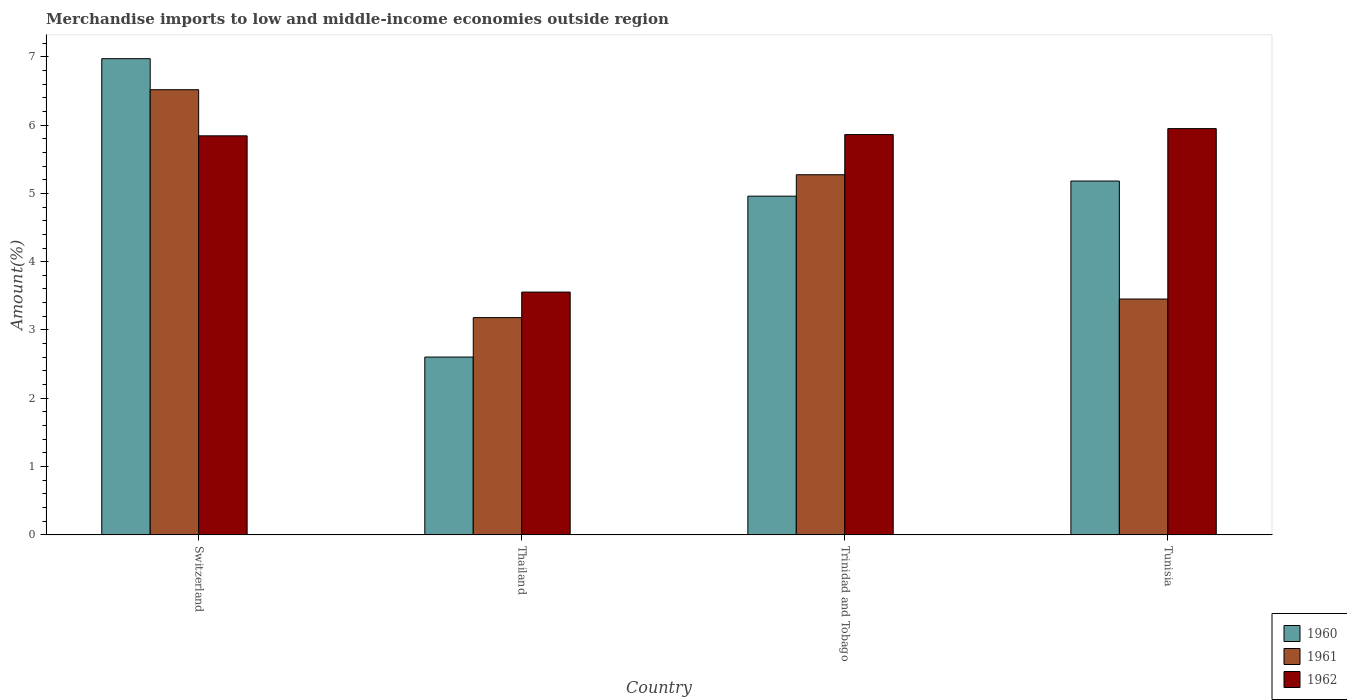How many groups of bars are there?
Ensure brevity in your answer.  4. Are the number of bars on each tick of the X-axis equal?
Your response must be concise. Yes. What is the label of the 4th group of bars from the left?
Make the answer very short. Tunisia. In how many cases, is the number of bars for a given country not equal to the number of legend labels?
Your response must be concise. 0. What is the percentage of amount earned from merchandise imports in 1962 in Thailand?
Your answer should be very brief. 3.55. Across all countries, what is the maximum percentage of amount earned from merchandise imports in 1962?
Provide a succinct answer. 5.95. Across all countries, what is the minimum percentage of amount earned from merchandise imports in 1962?
Provide a succinct answer. 3.55. In which country was the percentage of amount earned from merchandise imports in 1961 maximum?
Ensure brevity in your answer.  Switzerland. In which country was the percentage of amount earned from merchandise imports in 1962 minimum?
Your response must be concise. Thailand. What is the total percentage of amount earned from merchandise imports in 1960 in the graph?
Keep it short and to the point. 19.71. What is the difference between the percentage of amount earned from merchandise imports in 1960 in Thailand and that in Trinidad and Tobago?
Provide a succinct answer. -2.36. What is the difference between the percentage of amount earned from merchandise imports in 1960 in Switzerland and the percentage of amount earned from merchandise imports in 1961 in Tunisia?
Your answer should be compact. 3.52. What is the average percentage of amount earned from merchandise imports in 1960 per country?
Ensure brevity in your answer.  4.93. What is the difference between the percentage of amount earned from merchandise imports of/in 1962 and percentage of amount earned from merchandise imports of/in 1961 in Tunisia?
Your answer should be compact. 2.49. What is the ratio of the percentage of amount earned from merchandise imports in 1962 in Switzerland to that in Trinidad and Tobago?
Make the answer very short. 1. Is the percentage of amount earned from merchandise imports in 1962 in Thailand less than that in Trinidad and Tobago?
Offer a terse response. Yes. Is the difference between the percentage of amount earned from merchandise imports in 1962 in Trinidad and Tobago and Tunisia greater than the difference between the percentage of amount earned from merchandise imports in 1961 in Trinidad and Tobago and Tunisia?
Offer a very short reply. No. What is the difference between the highest and the second highest percentage of amount earned from merchandise imports in 1960?
Offer a very short reply. -0.22. What is the difference between the highest and the lowest percentage of amount earned from merchandise imports in 1960?
Provide a succinct answer. 4.37. Is the sum of the percentage of amount earned from merchandise imports in 1960 in Thailand and Tunisia greater than the maximum percentage of amount earned from merchandise imports in 1962 across all countries?
Provide a short and direct response. Yes. What does the 2nd bar from the left in Tunisia represents?
Give a very brief answer. 1961. What does the 1st bar from the right in Switzerland represents?
Keep it short and to the point. 1962. How many countries are there in the graph?
Give a very brief answer. 4. Are the values on the major ticks of Y-axis written in scientific E-notation?
Your answer should be compact. No. Does the graph contain grids?
Provide a short and direct response. No. How many legend labels are there?
Offer a terse response. 3. How are the legend labels stacked?
Offer a very short reply. Vertical. What is the title of the graph?
Make the answer very short. Merchandise imports to low and middle-income economies outside region. What is the label or title of the X-axis?
Your answer should be compact. Country. What is the label or title of the Y-axis?
Give a very brief answer. Amount(%). What is the Amount(%) of 1960 in Switzerland?
Give a very brief answer. 6.97. What is the Amount(%) in 1961 in Switzerland?
Your response must be concise. 6.52. What is the Amount(%) in 1962 in Switzerland?
Offer a terse response. 5.84. What is the Amount(%) in 1960 in Thailand?
Ensure brevity in your answer.  2.6. What is the Amount(%) in 1961 in Thailand?
Ensure brevity in your answer.  3.18. What is the Amount(%) in 1962 in Thailand?
Offer a very short reply. 3.55. What is the Amount(%) of 1960 in Trinidad and Tobago?
Provide a succinct answer. 4.96. What is the Amount(%) in 1961 in Trinidad and Tobago?
Your answer should be very brief. 5.27. What is the Amount(%) of 1962 in Trinidad and Tobago?
Your response must be concise. 5.86. What is the Amount(%) in 1960 in Tunisia?
Provide a short and direct response. 5.18. What is the Amount(%) of 1961 in Tunisia?
Keep it short and to the point. 3.45. What is the Amount(%) in 1962 in Tunisia?
Provide a succinct answer. 5.95. Across all countries, what is the maximum Amount(%) in 1960?
Your answer should be very brief. 6.97. Across all countries, what is the maximum Amount(%) of 1961?
Offer a terse response. 6.52. Across all countries, what is the maximum Amount(%) of 1962?
Your response must be concise. 5.95. Across all countries, what is the minimum Amount(%) of 1960?
Your answer should be very brief. 2.6. Across all countries, what is the minimum Amount(%) in 1961?
Your response must be concise. 3.18. Across all countries, what is the minimum Amount(%) in 1962?
Offer a very short reply. 3.55. What is the total Amount(%) of 1960 in the graph?
Give a very brief answer. 19.71. What is the total Amount(%) of 1961 in the graph?
Keep it short and to the point. 18.42. What is the total Amount(%) in 1962 in the graph?
Your answer should be compact. 21.21. What is the difference between the Amount(%) of 1960 in Switzerland and that in Thailand?
Offer a very short reply. 4.37. What is the difference between the Amount(%) in 1961 in Switzerland and that in Thailand?
Keep it short and to the point. 3.34. What is the difference between the Amount(%) in 1962 in Switzerland and that in Thailand?
Your answer should be very brief. 2.29. What is the difference between the Amount(%) of 1960 in Switzerland and that in Trinidad and Tobago?
Your answer should be compact. 2.01. What is the difference between the Amount(%) of 1961 in Switzerland and that in Trinidad and Tobago?
Keep it short and to the point. 1.25. What is the difference between the Amount(%) in 1962 in Switzerland and that in Trinidad and Tobago?
Ensure brevity in your answer.  -0.02. What is the difference between the Amount(%) of 1960 in Switzerland and that in Tunisia?
Provide a succinct answer. 1.79. What is the difference between the Amount(%) in 1961 in Switzerland and that in Tunisia?
Make the answer very short. 3.06. What is the difference between the Amount(%) in 1962 in Switzerland and that in Tunisia?
Make the answer very short. -0.11. What is the difference between the Amount(%) in 1960 in Thailand and that in Trinidad and Tobago?
Make the answer very short. -2.36. What is the difference between the Amount(%) in 1961 in Thailand and that in Trinidad and Tobago?
Give a very brief answer. -2.09. What is the difference between the Amount(%) of 1962 in Thailand and that in Trinidad and Tobago?
Provide a succinct answer. -2.31. What is the difference between the Amount(%) in 1960 in Thailand and that in Tunisia?
Provide a short and direct response. -2.58. What is the difference between the Amount(%) of 1961 in Thailand and that in Tunisia?
Your answer should be very brief. -0.27. What is the difference between the Amount(%) in 1962 in Thailand and that in Tunisia?
Ensure brevity in your answer.  -2.39. What is the difference between the Amount(%) in 1960 in Trinidad and Tobago and that in Tunisia?
Provide a succinct answer. -0.22. What is the difference between the Amount(%) of 1961 in Trinidad and Tobago and that in Tunisia?
Provide a succinct answer. 1.82. What is the difference between the Amount(%) of 1962 in Trinidad and Tobago and that in Tunisia?
Make the answer very short. -0.09. What is the difference between the Amount(%) of 1960 in Switzerland and the Amount(%) of 1961 in Thailand?
Your answer should be very brief. 3.79. What is the difference between the Amount(%) of 1960 in Switzerland and the Amount(%) of 1962 in Thailand?
Ensure brevity in your answer.  3.42. What is the difference between the Amount(%) in 1961 in Switzerland and the Amount(%) in 1962 in Thailand?
Give a very brief answer. 2.96. What is the difference between the Amount(%) in 1960 in Switzerland and the Amount(%) in 1961 in Trinidad and Tobago?
Give a very brief answer. 1.7. What is the difference between the Amount(%) of 1960 in Switzerland and the Amount(%) of 1962 in Trinidad and Tobago?
Make the answer very short. 1.11. What is the difference between the Amount(%) of 1961 in Switzerland and the Amount(%) of 1962 in Trinidad and Tobago?
Make the answer very short. 0.66. What is the difference between the Amount(%) in 1960 in Switzerland and the Amount(%) in 1961 in Tunisia?
Your response must be concise. 3.52. What is the difference between the Amount(%) of 1960 in Switzerland and the Amount(%) of 1962 in Tunisia?
Keep it short and to the point. 1.02. What is the difference between the Amount(%) in 1961 in Switzerland and the Amount(%) in 1962 in Tunisia?
Keep it short and to the point. 0.57. What is the difference between the Amount(%) in 1960 in Thailand and the Amount(%) in 1961 in Trinidad and Tobago?
Provide a succinct answer. -2.67. What is the difference between the Amount(%) in 1960 in Thailand and the Amount(%) in 1962 in Trinidad and Tobago?
Offer a terse response. -3.26. What is the difference between the Amount(%) in 1961 in Thailand and the Amount(%) in 1962 in Trinidad and Tobago?
Offer a very short reply. -2.68. What is the difference between the Amount(%) of 1960 in Thailand and the Amount(%) of 1961 in Tunisia?
Your answer should be very brief. -0.85. What is the difference between the Amount(%) of 1960 in Thailand and the Amount(%) of 1962 in Tunisia?
Keep it short and to the point. -3.34. What is the difference between the Amount(%) of 1961 in Thailand and the Amount(%) of 1962 in Tunisia?
Ensure brevity in your answer.  -2.77. What is the difference between the Amount(%) in 1960 in Trinidad and Tobago and the Amount(%) in 1961 in Tunisia?
Give a very brief answer. 1.51. What is the difference between the Amount(%) of 1960 in Trinidad and Tobago and the Amount(%) of 1962 in Tunisia?
Offer a terse response. -0.99. What is the difference between the Amount(%) in 1961 in Trinidad and Tobago and the Amount(%) in 1962 in Tunisia?
Ensure brevity in your answer.  -0.68. What is the average Amount(%) in 1960 per country?
Give a very brief answer. 4.93. What is the average Amount(%) in 1961 per country?
Offer a terse response. 4.61. What is the average Amount(%) of 1962 per country?
Your answer should be very brief. 5.3. What is the difference between the Amount(%) in 1960 and Amount(%) in 1961 in Switzerland?
Your answer should be very brief. 0.45. What is the difference between the Amount(%) of 1960 and Amount(%) of 1962 in Switzerland?
Your response must be concise. 1.13. What is the difference between the Amount(%) of 1961 and Amount(%) of 1962 in Switzerland?
Provide a succinct answer. 0.68. What is the difference between the Amount(%) in 1960 and Amount(%) in 1961 in Thailand?
Offer a terse response. -0.58. What is the difference between the Amount(%) of 1960 and Amount(%) of 1962 in Thailand?
Your answer should be compact. -0.95. What is the difference between the Amount(%) of 1961 and Amount(%) of 1962 in Thailand?
Offer a terse response. -0.37. What is the difference between the Amount(%) of 1960 and Amount(%) of 1961 in Trinidad and Tobago?
Offer a very short reply. -0.31. What is the difference between the Amount(%) of 1960 and Amount(%) of 1962 in Trinidad and Tobago?
Provide a short and direct response. -0.9. What is the difference between the Amount(%) in 1961 and Amount(%) in 1962 in Trinidad and Tobago?
Your answer should be very brief. -0.59. What is the difference between the Amount(%) in 1960 and Amount(%) in 1961 in Tunisia?
Give a very brief answer. 1.73. What is the difference between the Amount(%) of 1960 and Amount(%) of 1962 in Tunisia?
Keep it short and to the point. -0.77. What is the difference between the Amount(%) of 1961 and Amount(%) of 1962 in Tunisia?
Offer a terse response. -2.49. What is the ratio of the Amount(%) in 1960 in Switzerland to that in Thailand?
Offer a terse response. 2.68. What is the ratio of the Amount(%) of 1961 in Switzerland to that in Thailand?
Provide a succinct answer. 2.05. What is the ratio of the Amount(%) of 1962 in Switzerland to that in Thailand?
Give a very brief answer. 1.64. What is the ratio of the Amount(%) in 1960 in Switzerland to that in Trinidad and Tobago?
Make the answer very short. 1.41. What is the ratio of the Amount(%) in 1961 in Switzerland to that in Trinidad and Tobago?
Provide a succinct answer. 1.24. What is the ratio of the Amount(%) in 1960 in Switzerland to that in Tunisia?
Provide a short and direct response. 1.35. What is the ratio of the Amount(%) in 1961 in Switzerland to that in Tunisia?
Offer a very short reply. 1.89. What is the ratio of the Amount(%) of 1962 in Switzerland to that in Tunisia?
Provide a succinct answer. 0.98. What is the ratio of the Amount(%) of 1960 in Thailand to that in Trinidad and Tobago?
Provide a succinct answer. 0.53. What is the ratio of the Amount(%) of 1961 in Thailand to that in Trinidad and Tobago?
Your answer should be compact. 0.6. What is the ratio of the Amount(%) of 1962 in Thailand to that in Trinidad and Tobago?
Your answer should be compact. 0.61. What is the ratio of the Amount(%) of 1960 in Thailand to that in Tunisia?
Ensure brevity in your answer.  0.5. What is the ratio of the Amount(%) of 1961 in Thailand to that in Tunisia?
Provide a short and direct response. 0.92. What is the ratio of the Amount(%) in 1962 in Thailand to that in Tunisia?
Ensure brevity in your answer.  0.6. What is the ratio of the Amount(%) of 1960 in Trinidad and Tobago to that in Tunisia?
Offer a terse response. 0.96. What is the ratio of the Amount(%) of 1961 in Trinidad and Tobago to that in Tunisia?
Your response must be concise. 1.53. What is the ratio of the Amount(%) in 1962 in Trinidad and Tobago to that in Tunisia?
Make the answer very short. 0.99. What is the difference between the highest and the second highest Amount(%) of 1960?
Offer a very short reply. 1.79. What is the difference between the highest and the second highest Amount(%) in 1961?
Offer a terse response. 1.25. What is the difference between the highest and the second highest Amount(%) of 1962?
Provide a short and direct response. 0.09. What is the difference between the highest and the lowest Amount(%) of 1960?
Give a very brief answer. 4.37. What is the difference between the highest and the lowest Amount(%) in 1961?
Your response must be concise. 3.34. What is the difference between the highest and the lowest Amount(%) of 1962?
Give a very brief answer. 2.39. 